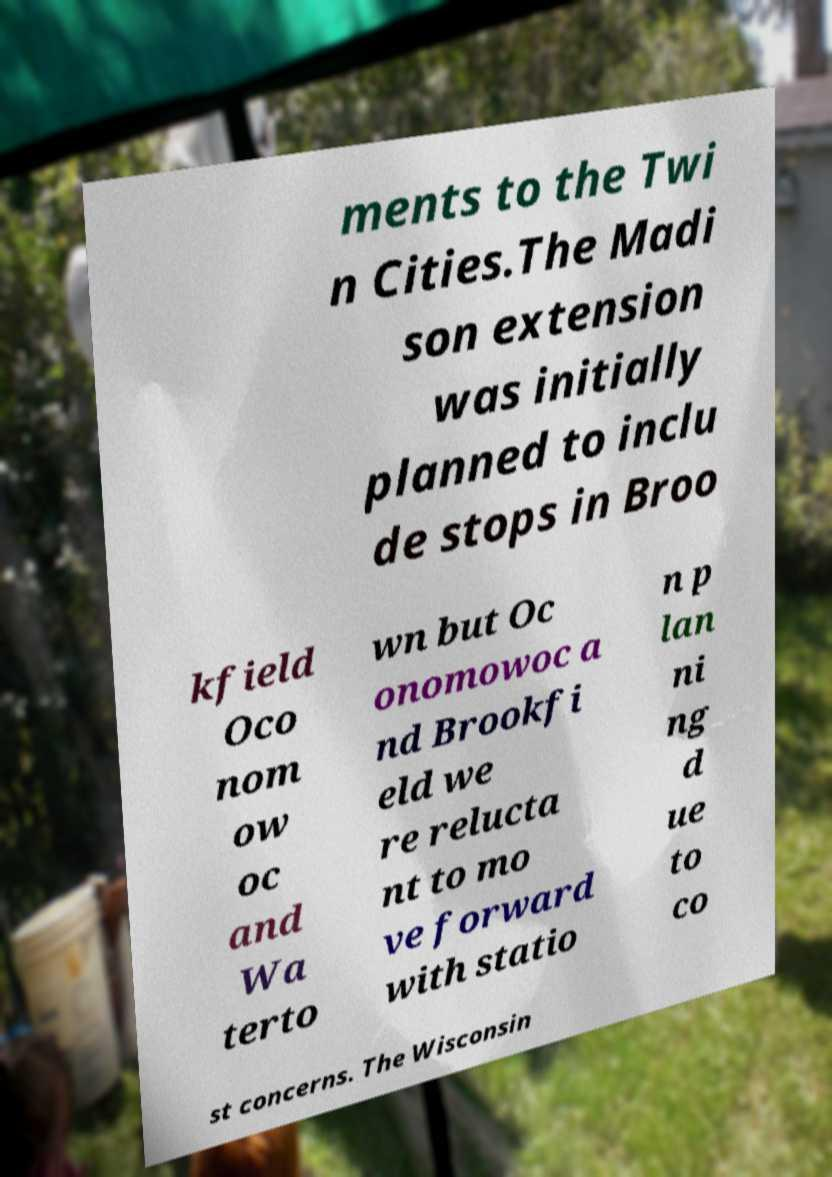Can you read and provide the text displayed in the image?This photo seems to have some interesting text. Can you extract and type it out for me? ments to the Twi n Cities.The Madi son extension was initially planned to inclu de stops in Broo kfield Oco nom ow oc and Wa terto wn but Oc onomowoc a nd Brookfi eld we re relucta nt to mo ve forward with statio n p lan ni ng d ue to co st concerns. The Wisconsin 